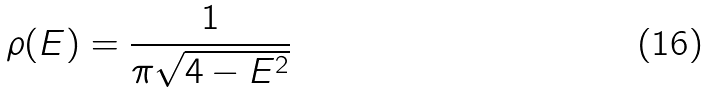Convert formula to latex. <formula><loc_0><loc_0><loc_500><loc_500>\rho ( E ) = \frac { 1 } { \pi \sqrt { 4 - E ^ { 2 } } }</formula> 